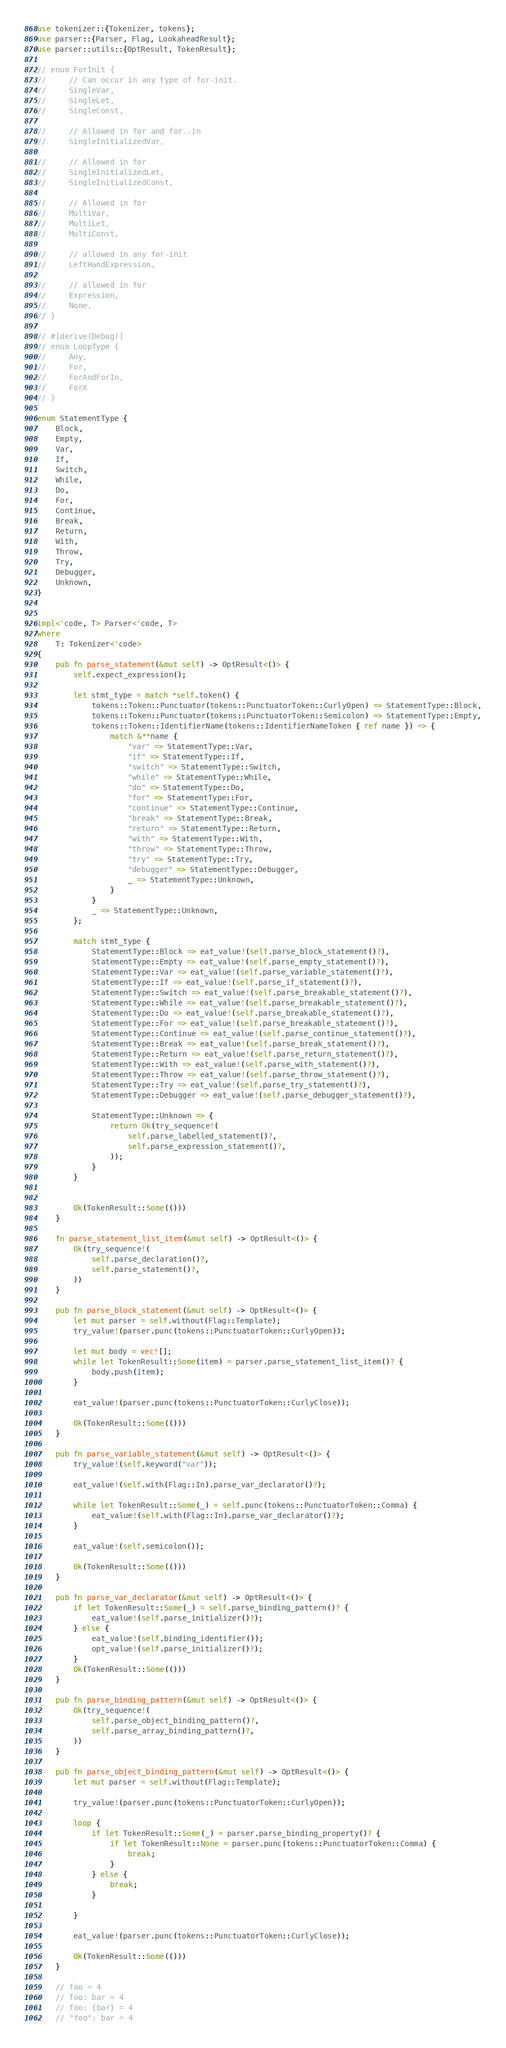<code> <loc_0><loc_0><loc_500><loc_500><_Rust_>
use tokenizer::{Tokenizer, tokens};
use parser::{Parser, Flag, LookaheadResult};
use parser::utils::{OptResult, TokenResult};

// enum ForInit {
//     // Can occur in any type of for-init.
//     SingleVar,
//     SingleLet,
//     SingleConst,

//     // Allowed in for and for..in
//     SingleInitializedVar,

//     // Allowed in for
//     SingleInitializedLet,
//     SingleInitializedConst,

//     // Allowed in for
//     MultiVar,
//     MultiLet,
//     MultiConst,

//     // allowed in any for-init
//     LeftHandExpression,

//     // allowed in for
//     Expression,
//     None,
// }

// #[derive(Debug)]
// enum LoopType {
//     Any,
//     For,
//     ForAndForIn,
//     ForX
// }

enum StatementType {
    Block,
    Empty,
    Var,
    If,
    Switch,
    While,
    Do,
    For,
    Continue,
    Break,
    Return,
    With,
    Throw,
    Try,
    Debugger,
    Unknown,
}


impl<'code, T> Parser<'code, T>
where
    T: Tokenizer<'code>
{
    pub fn parse_statement(&mut self) -> OptResult<()> {
        self.expect_expression();

        let stmt_type = match *self.token() {
            tokens::Token::Punctuator(tokens::PunctuatorToken::CurlyOpen) => StatementType::Block,
            tokens::Token::Punctuator(tokens::PunctuatorToken::Semicolon) => StatementType::Empty,
            tokens::Token::IdentifierName(tokens::IdentifierNameToken { ref name }) => {
                match &**name {
                    "var" => StatementType::Var,
                    "if" => StatementType::If,
                    "switch" => StatementType::Switch,
                    "while" => StatementType::While,
                    "do" => StatementType::Do,
                    "for" => StatementType::For,
                    "continue" => StatementType::Continue,
                    "break" => StatementType::Break,
                    "return" => StatementType::Return,
                    "with" => StatementType::With,
                    "throw" => StatementType::Throw,
                    "try" => StatementType::Try,
                    "debugger" => StatementType::Debugger,
                    _ => StatementType::Unknown,
                }
            }
            _ => StatementType::Unknown,
        };

        match stmt_type {
            StatementType::Block => eat_value!(self.parse_block_statement()?),
            StatementType::Empty => eat_value!(self.parse_empty_statement()?),
            StatementType::Var => eat_value!(self.parse_variable_statement()?),
            StatementType::If => eat_value!(self.parse_if_statement()?),
            StatementType::Switch => eat_value!(self.parse_breakable_statement()?),
            StatementType::While => eat_value!(self.parse_breakable_statement()?),
            StatementType::Do => eat_value!(self.parse_breakable_statement()?),
            StatementType::For => eat_value!(self.parse_breakable_statement()?),
            StatementType::Continue => eat_value!(self.parse_continue_statement()?),
            StatementType::Break => eat_value!(self.parse_break_statement()?),
            StatementType::Return => eat_value!(self.parse_return_statement()?),
            StatementType::With => eat_value!(self.parse_with_statement()?),
            StatementType::Throw => eat_value!(self.parse_throw_statement()?),
            StatementType::Try => eat_value!(self.parse_try_statement()?),
            StatementType::Debugger => eat_value!(self.parse_debugger_statement()?),

            StatementType::Unknown => {
                return Ok(try_sequence!(
                    self.parse_labelled_statement()?,
                    self.parse_expression_statement()?,
                ));
            }
        }


        Ok(TokenResult::Some(()))
    }

    fn parse_statement_list_item(&mut self) -> OptResult<()> {
        Ok(try_sequence!(
            self.parse_declaration()?,
            self.parse_statement()?,
        ))
    }

    pub fn parse_block_statement(&mut self) -> OptResult<()> {
        let mut parser = self.without(Flag::Template);
        try_value!(parser.punc(tokens::PunctuatorToken::CurlyOpen));

        let mut body = vec![];
        while let TokenResult::Some(item) = parser.parse_statement_list_item()? {
            body.push(item);
        }

        eat_value!(parser.punc(tokens::PunctuatorToken::CurlyClose));

        Ok(TokenResult::Some(()))
    }

    pub fn parse_variable_statement(&mut self) -> OptResult<()> {
        try_value!(self.keyword("var"));

        eat_value!(self.with(Flag::In).parse_var_declarator()?);

        while let TokenResult::Some(_) = self.punc(tokens::PunctuatorToken::Comma) {
            eat_value!(self.with(Flag::In).parse_var_declarator()?);
        }

        eat_value!(self.semicolon());

        Ok(TokenResult::Some(()))
    }

    pub fn parse_var_declarator(&mut self) -> OptResult<()> {
        if let TokenResult::Some(_) = self.parse_binding_pattern()? {
            eat_value!(self.parse_initializer()?);
        } else {
            eat_value!(self.binding_identifier());
            opt_value!(self.parse_initializer()?);
        }
        Ok(TokenResult::Some(()))
    }

    pub fn parse_binding_pattern(&mut self) -> OptResult<()> {
        Ok(try_sequence!(
            self.parse_object_binding_pattern()?,
            self.parse_array_binding_pattern()?,
        ))
    }

    pub fn parse_object_binding_pattern(&mut self) -> OptResult<()> {
        let mut parser = self.without(Flag::Template);

        try_value!(parser.punc(tokens::PunctuatorToken::CurlyOpen));

        loop {
            if let TokenResult::Some(_) = parser.parse_binding_property()? {
                if let TokenResult::None = parser.punc(tokens::PunctuatorToken::Comma) {
                    break;
                }
            } else {
                break;
            }

        }

        eat_value!(parser.punc(tokens::PunctuatorToken::CurlyClose));

        Ok(TokenResult::Some(()))
    }

    // foo = 4
    // foo: bar = 4
    // foo: {bar} = 4
    // "foo": bar = 4</code> 